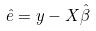<formula> <loc_0><loc_0><loc_500><loc_500>\hat { e } = y - X \hat { \beta }</formula> 